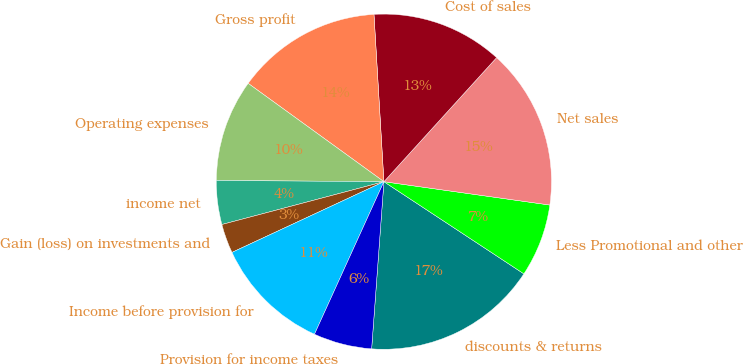Convert chart to OTSL. <chart><loc_0><loc_0><loc_500><loc_500><pie_chart><fcel>discounts & returns<fcel>Less Promotional and other<fcel>Net sales<fcel>Cost of sales<fcel>Gross profit<fcel>Operating expenses<fcel>income net<fcel>Gain (loss) on investments and<fcel>Income before provision for<fcel>Provision for income taxes<nl><fcel>16.9%<fcel>7.04%<fcel>15.49%<fcel>12.68%<fcel>14.08%<fcel>9.86%<fcel>4.23%<fcel>2.82%<fcel>11.27%<fcel>5.63%<nl></chart> 